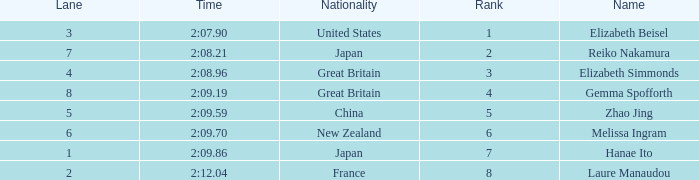What is Laure Manaudou's highest rank? 8.0. 